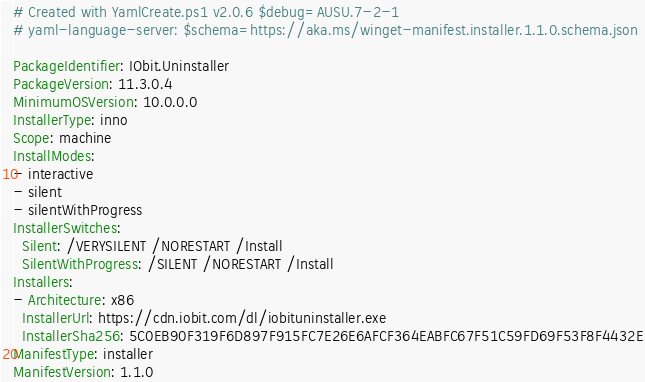Convert code to text. <code><loc_0><loc_0><loc_500><loc_500><_YAML_># Created with YamlCreate.ps1 v2.0.6 $debug=AUSU.7-2-1
# yaml-language-server: $schema=https://aka.ms/winget-manifest.installer.1.1.0.schema.json

PackageIdentifier: IObit.Uninstaller
PackageVersion: 11.3.0.4
MinimumOSVersion: 10.0.0.0
InstallerType: inno
Scope: machine
InstallModes:
- interactive
- silent
- silentWithProgress
InstallerSwitches:
  Silent: /VERYSILENT /NORESTART /Install
  SilentWithProgress: /SILENT /NORESTART /Install
Installers:
- Architecture: x86
  InstallerUrl: https://cdn.iobit.com/dl/iobituninstaller.exe
  InstallerSha256: 5C0EB90F319F6D897F915FC7E26E6AFCF364EABFC67F51C59FD69F53F8F4432E
ManifestType: installer
ManifestVersion: 1.1.0
</code> 